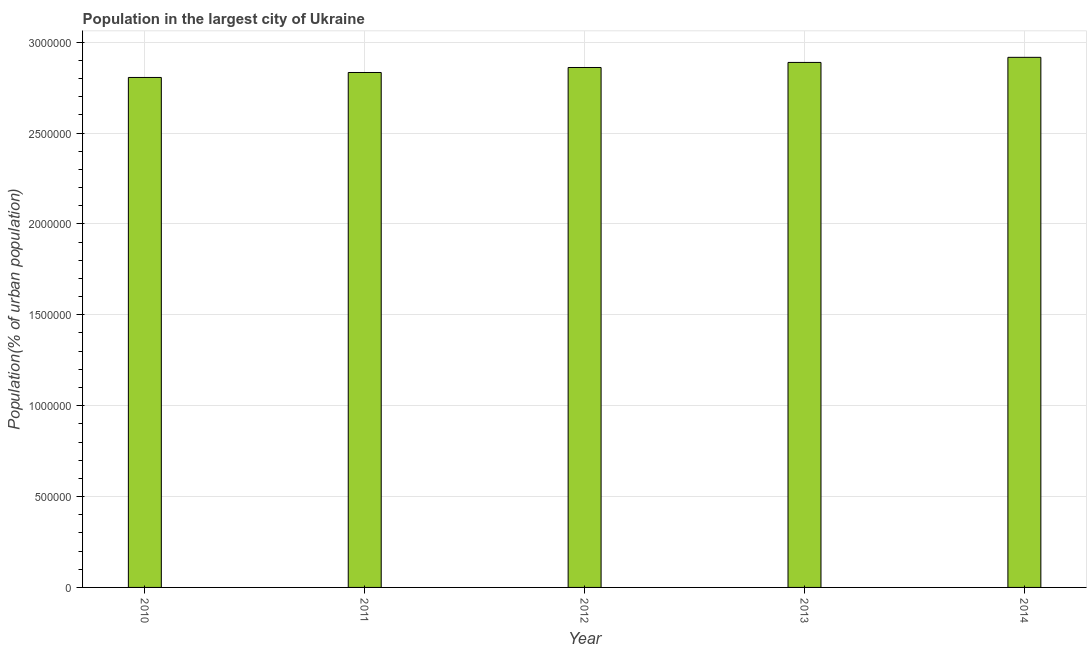What is the title of the graph?
Offer a very short reply. Population in the largest city of Ukraine. What is the label or title of the Y-axis?
Keep it short and to the point. Population(% of urban population). What is the population in largest city in 2010?
Provide a short and direct response. 2.81e+06. Across all years, what is the maximum population in largest city?
Provide a succinct answer. 2.92e+06. Across all years, what is the minimum population in largest city?
Your response must be concise. 2.81e+06. In which year was the population in largest city maximum?
Give a very brief answer. 2014. In which year was the population in largest city minimum?
Your answer should be compact. 2010. What is the sum of the population in largest city?
Provide a short and direct response. 1.43e+07. What is the difference between the population in largest city in 2011 and 2013?
Your response must be concise. -5.54e+04. What is the average population in largest city per year?
Provide a succinct answer. 2.86e+06. What is the median population in largest city?
Provide a short and direct response. 2.86e+06. In how many years, is the population in largest city greater than 2200000 %?
Make the answer very short. 5. What is the difference between the highest and the second highest population in largest city?
Give a very brief answer. 2.81e+04. Is the sum of the population in largest city in 2011 and 2012 greater than the maximum population in largest city across all years?
Your answer should be compact. Yes. What is the difference between the highest and the lowest population in largest city?
Offer a terse response. 1.11e+05. Are all the bars in the graph horizontal?
Your answer should be very brief. No. What is the difference between two consecutive major ticks on the Y-axis?
Your response must be concise. 5.00e+05. What is the Population(% of urban population) of 2010?
Give a very brief answer. 2.81e+06. What is the Population(% of urban population) of 2011?
Keep it short and to the point. 2.83e+06. What is the Population(% of urban population) in 2012?
Ensure brevity in your answer.  2.86e+06. What is the Population(% of urban population) of 2013?
Ensure brevity in your answer.  2.89e+06. What is the Population(% of urban population) of 2014?
Your response must be concise. 2.92e+06. What is the difference between the Population(% of urban population) in 2010 and 2011?
Your response must be concise. -2.73e+04. What is the difference between the Population(% of urban population) in 2010 and 2012?
Provide a short and direct response. -5.48e+04. What is the difference between the Population(% of urban population) in 2010 and 2013?
Provide a short and direct response. -8.26e+04. What is the difference between the Population(% of urban population) in 2010 and 2014?
Provide a short and direct response. -1.11e+05. What is the difference between the Population(% of urban population) in 2011 and 2012?
Offer a terse response. -2.75e+04. What is the difference between the Population(% of urban population) in 2011 and 2013?
Your response must be concise. -5.54e+04. What is the difference between the Population(% of urban population) in 2011 and 2014?
Your answer should be compact. -8.34e+04. What is the difference between the Population(% of urban population) in 2012 and 2013?
Your response must be concise. -2.78e+04. What is the difference between the Population(% of urban population) in 2012 and 2014?
Make the answer very short. -5.59e+04. What is the difference between the Population(% of urban population) in 2013 and 2014?
Your response must be concise. -2.81e+04. What is the ratio of the Population(% of urban population) in 2010 to that in 2012?
Your answer should be very brief. 0.98. What is the ratio of the Population(% of urban population) in 2010 to that in 2014?
Your answer should be compact. 0.96. What is the ratio of the Population(% of urban population) in 2011 to that in 2013?
Make the answer very short. 0.98. What is the ratio of the Population(% of urban population) in 2012 to that in 2013?
Offer a very short reply. 0.99. What is the ratio of the Population(% of urban population) in 2012 to that in 2014?
Your answer should be compact. 0.98. What is the ratio of the Population(% of urban population) in 2013 to that in 2014?
Give a very brief answer. 0.99. 